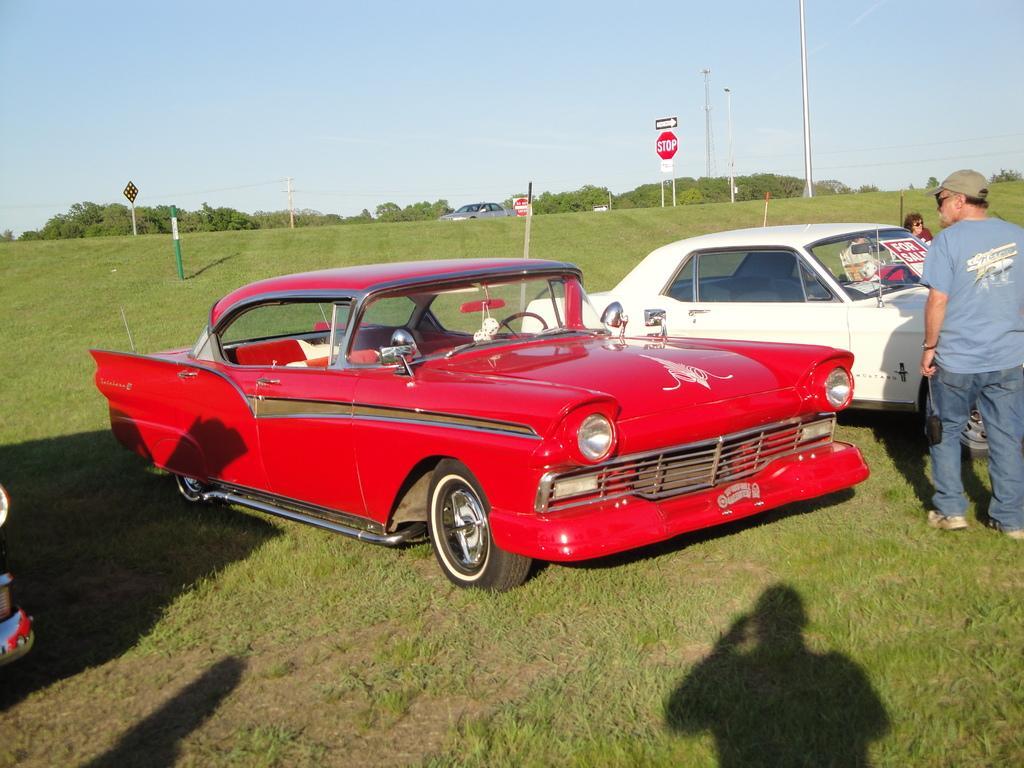Can you describe this image briefly? In this image, we can see few vehicles are parked on the grass. On the right side of the image, we can see few people. At the bottom, we can see humans shadows. Background there are few pole, sign boards, vehicle, trees and sky. 